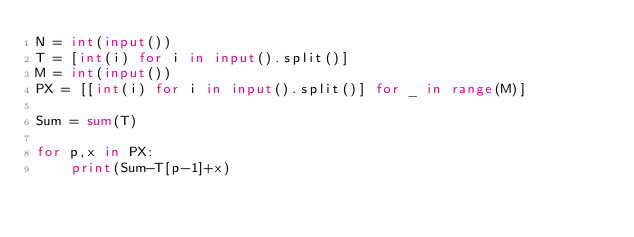<code> <loc_0><loc_0><loc_500><loc_500><_Python_>N = int(input())
T = [int(i) for i in input().split()]
M = int(input())
PX = [[int(i) for i in input().split()] for _ in range(M)]

Sum = sum(T)

for p,x in PX:
    print(Sum-T[p-1]+x)
</code> 